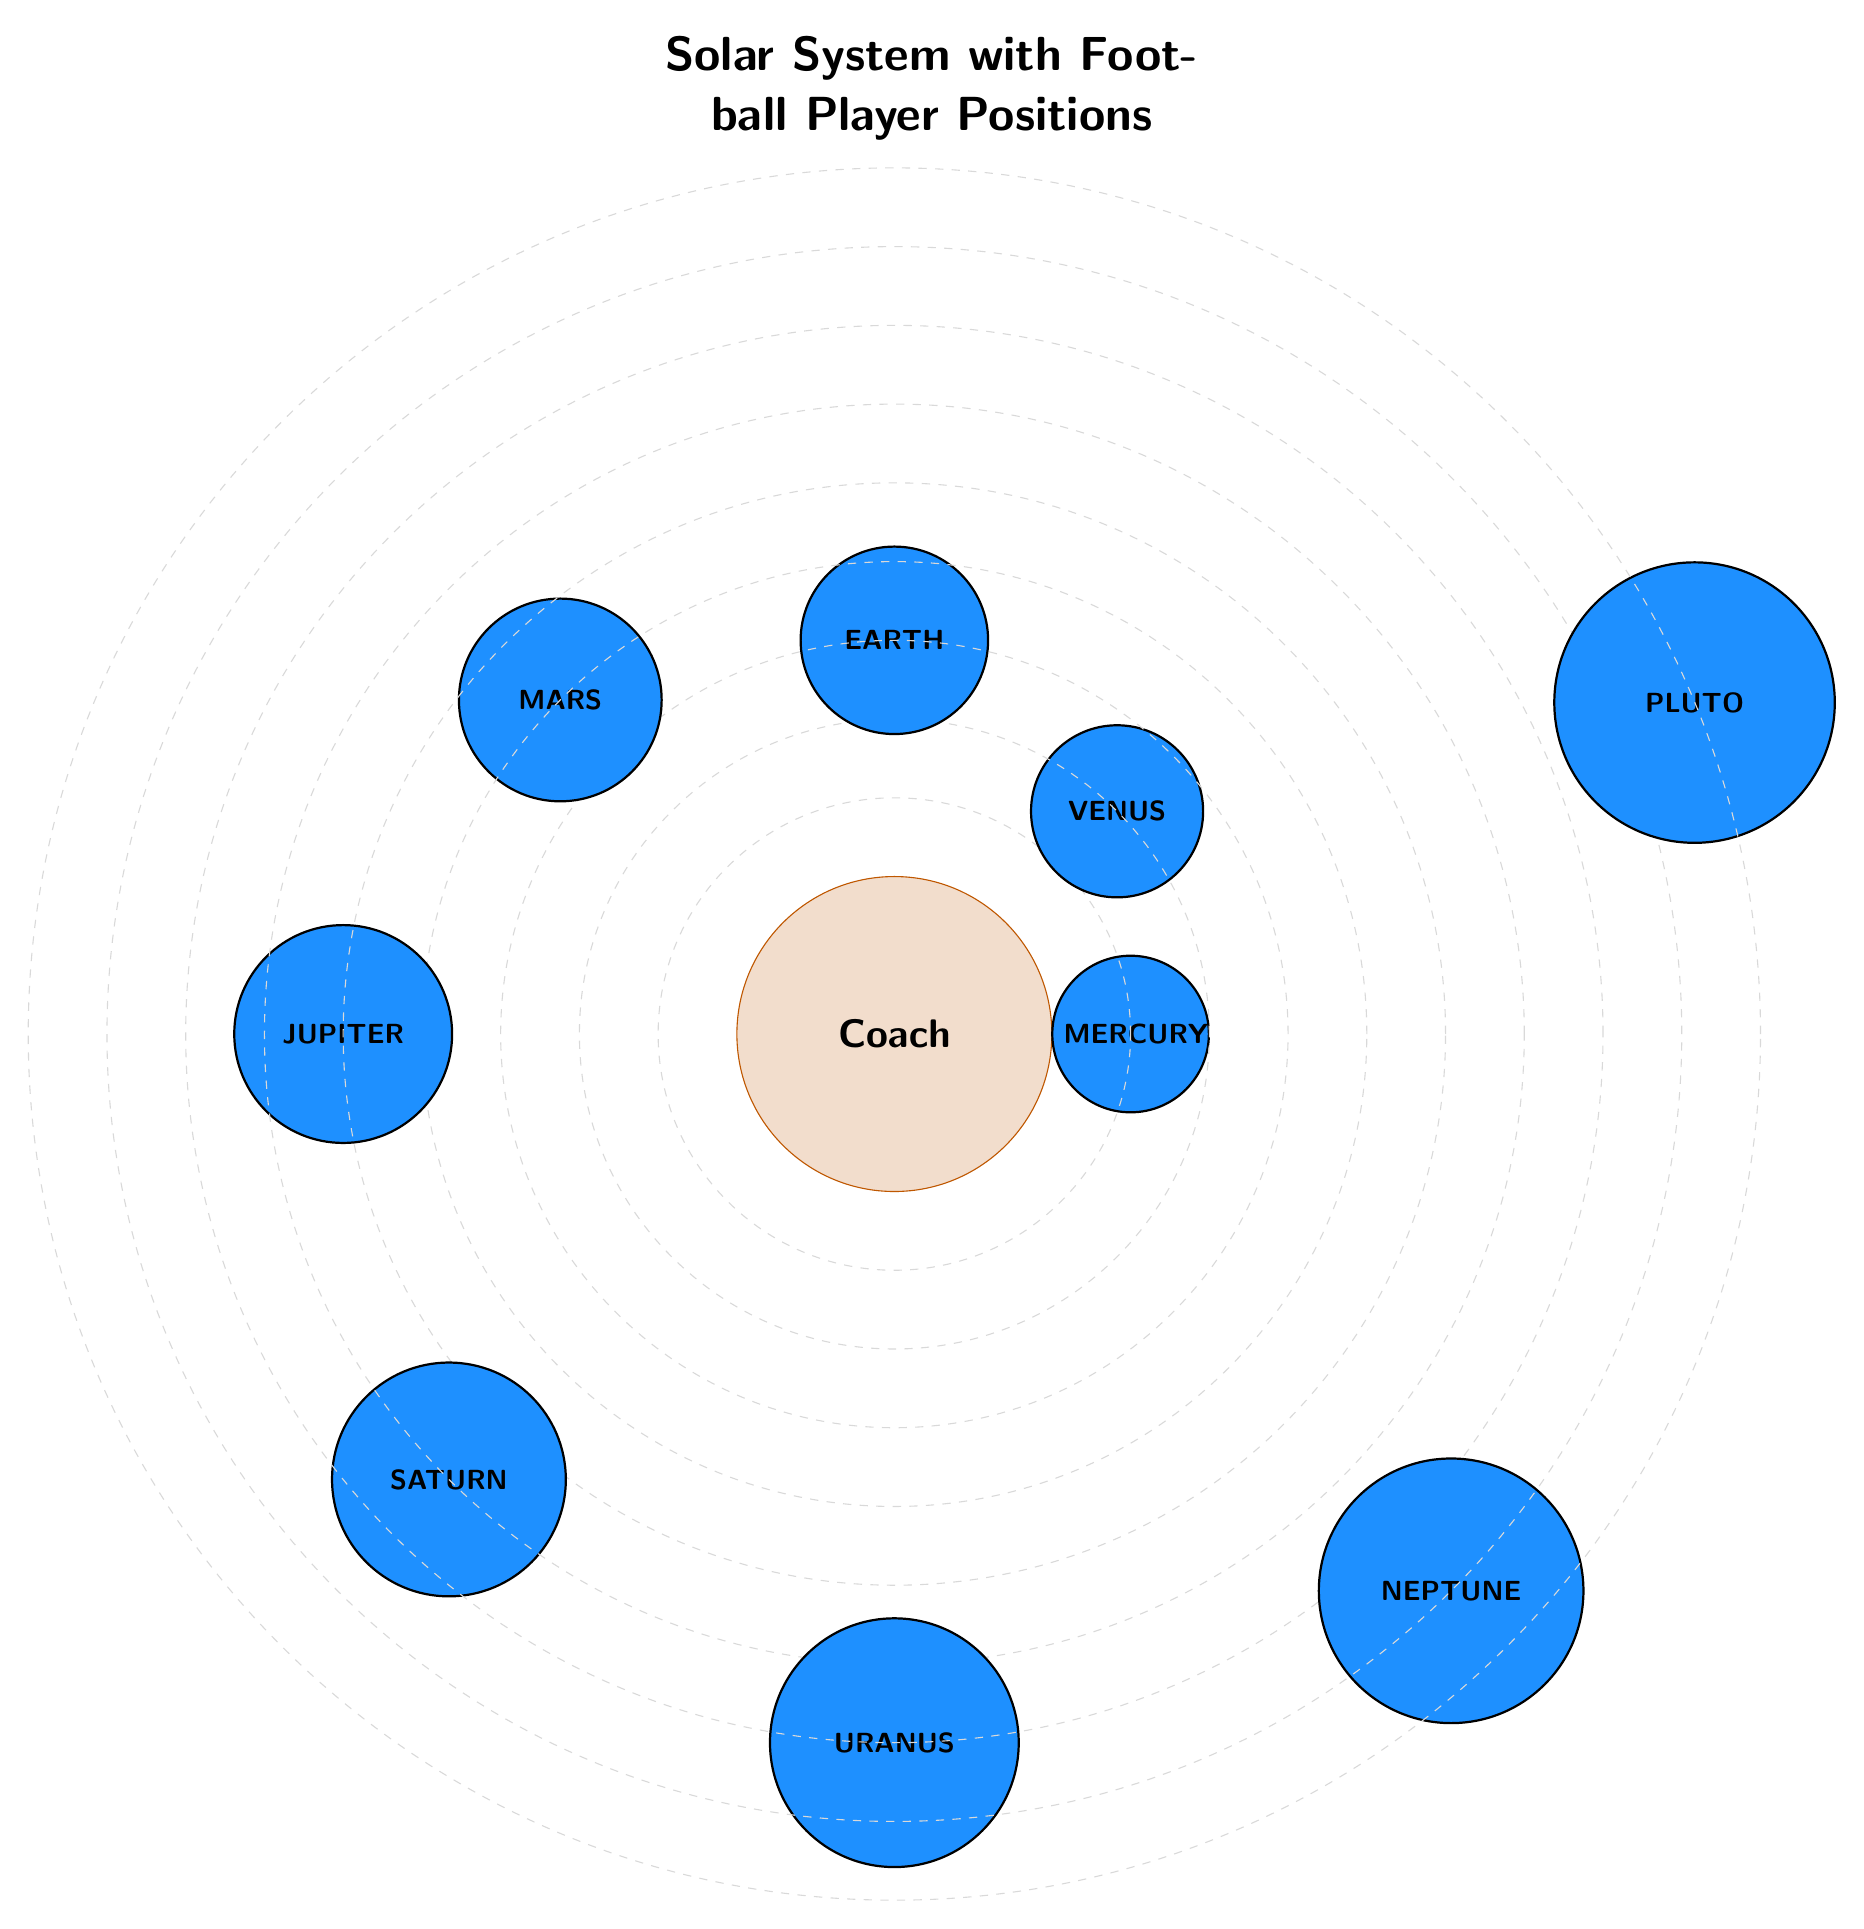What is the position of Jupiter in the Diagram? In the diagram, Jupiter is located at a 180-degree angle from the center (representing the Coach) and is positioned at a radius of 7 cm.
Answer: Jupiter How many planets are depicted in the diagram? The diagram has a total of 9 planets (Mercury, Venus, Earth, Mars, Jupiter, Saturn, Uranus, Neptune, and Pluto).
Answer: 9 Which player position is represented by Saturn? The label next to Saturn reads "Defensive Lineman," indicating that this is the corresponding player position in the diagram.
Answer: Defensive Lineman What is the radius distance from the Coach to Mars? According to the diagram, Mars is positioned at a radius of 6 cm from the Coach (the center).
Answer: 6 cm What is the angular position of Venus in the Solar System diagram? Venus is located at an angular position of 45 degrees with respect to the center (the Coach).
Answer: 45 degrees Which player position is farthest from the Coach? Since Pluto is located at the greatest radius of 11 cm from the center (Coach), the player position represented is "Safety."
Answer: Safety Which planet in the diagram is closest to the Coach? Mercury, positioned at a radius of 3 cm and an angle of 0 degrees, is the closest planet in the diagram to the Coach.
Answer: Mercury What is the angle of Neptune in relation to the Coach? Neptune's position is defined by an angle of 315 degrees in the diagram, relative to the center (Coach).
Answer: 315 degrees Which position has a radius of 8 cm and what is it? The player position at a radius of 8 cm is represented by Saturn, which corresponds to "Defensive Lineman."
Answer: Defensive Lineman 